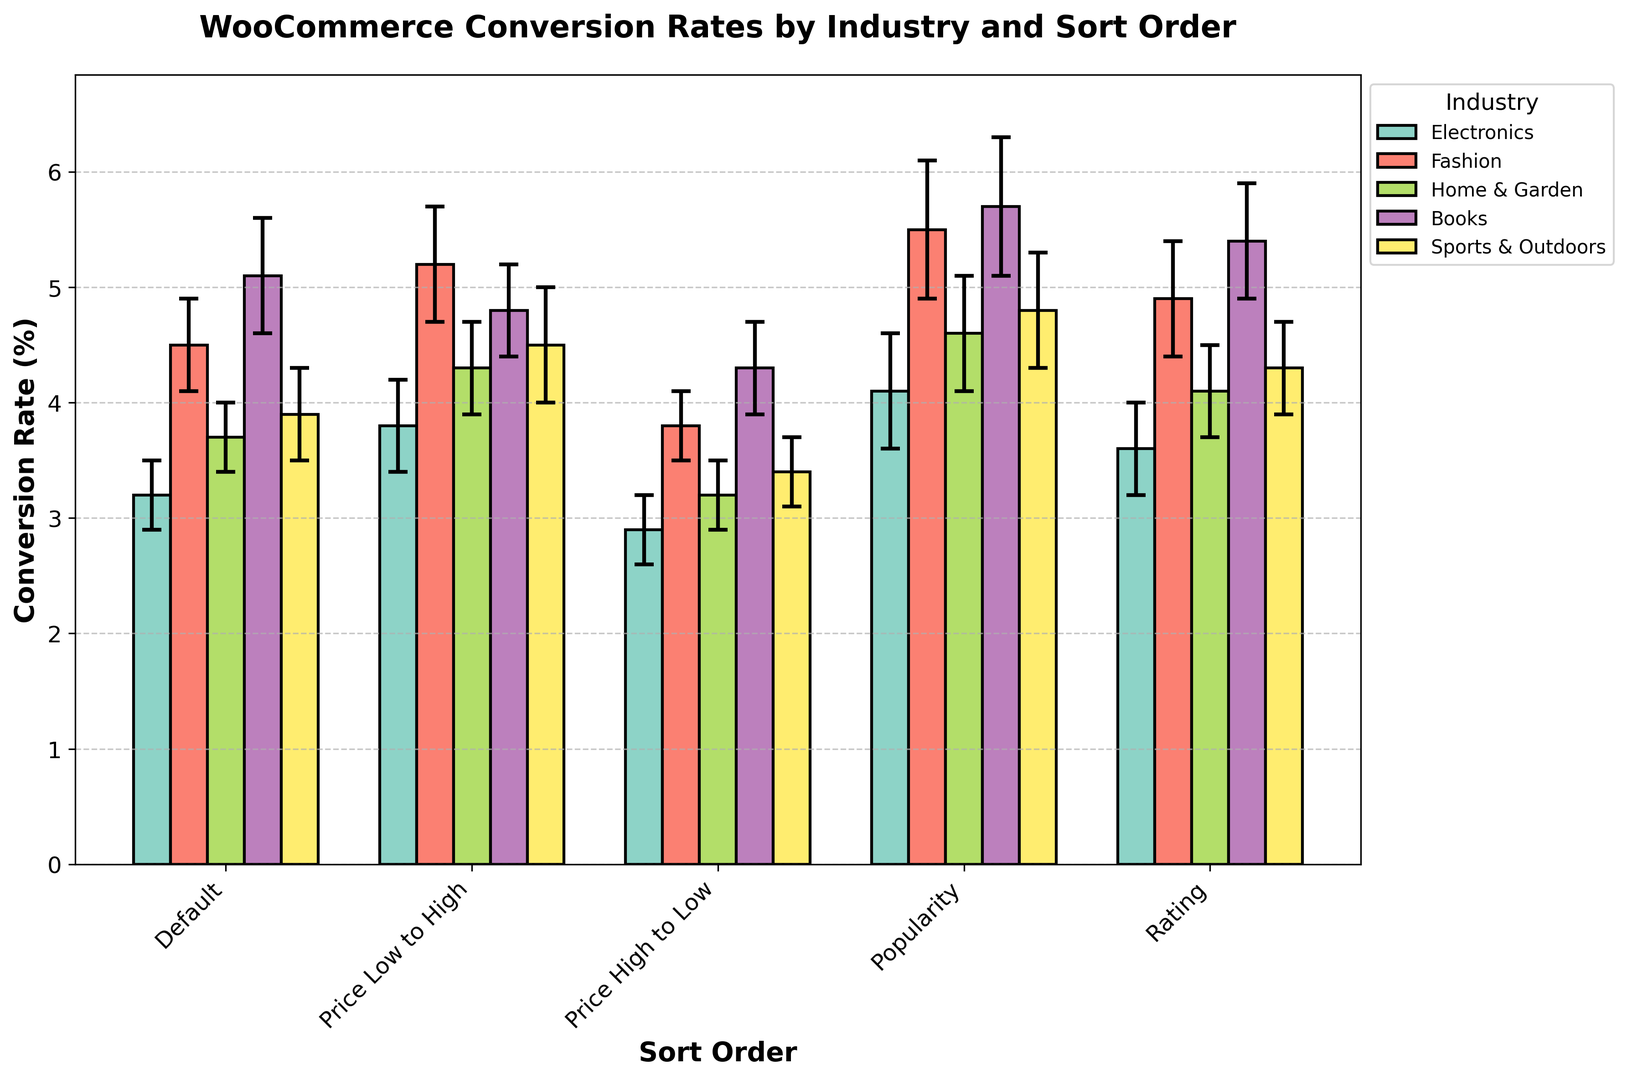Which sort order in the Electronics industry has the highest conversion rate? First, locate the Electronics industry bars. Then, compare the heights of these bars. The bar labeled "Popularity" is the tallest among them. Thus, the Electronics industry has the highest conversion rate when sorted by Popularity.
Answer: Popularity What is the difference in conversion rates between the default and popularity sort order for the Fashion industry? Identify the heights of the bars in the Fashion industry for the "Default" and "Popularity" sort orders. The Default bar has a height of 4.5 and the Popularity bar has a height of 5.5. The difference is 5.5 - 4.5 = 1.0.
Answer: 1.0 Which industry shows the smallest conversion rate for the "Price High to Low" sort order? Identify the bars for the "Price High to Low" sort order across industries. Compare their heights. The Electronics industry bar is the shortest.
Answer: Electronics For which sort order does the Home & Garden industry show the highest conversion rate? Locate all the bars for the Home & Garden industry. Compare their heights. The bar labeled "Popularity" is the tallest.
Answer: Popularity How do the conversion rates for the "Rating" sort order compare between the Books and Sports & Outdoors industries? Identify the bars for the "Rating" sort order in both the Books and Sports & Outdoors industries. The Books industry bar is taller than the Sports & Outdoors industry: 5.4 vs. 4.3.
Answer: Books is higher than Sports & Outdoors What is the average conversion rate for the Books industry across all sort orders? Identify the conversion rates for all sort orders in the Books industry: 5.1, 4.8, 4.3, 5.7, 5.4. Add these values: 5.1 + 4.8 + 4.3 + 5.7 + 5.4 = 25.3. Divide by the number of values: 25.3 / 5 = 5.06.
Answer: 5.06 Which industry shows the highest overall conversion rate for any sort order, and what is that rate? Identify the highest bars across all industries and sort orders. The tallest bar is for Books under "Popularity" with a height of 5.7.
Answer: Books, 5.7 